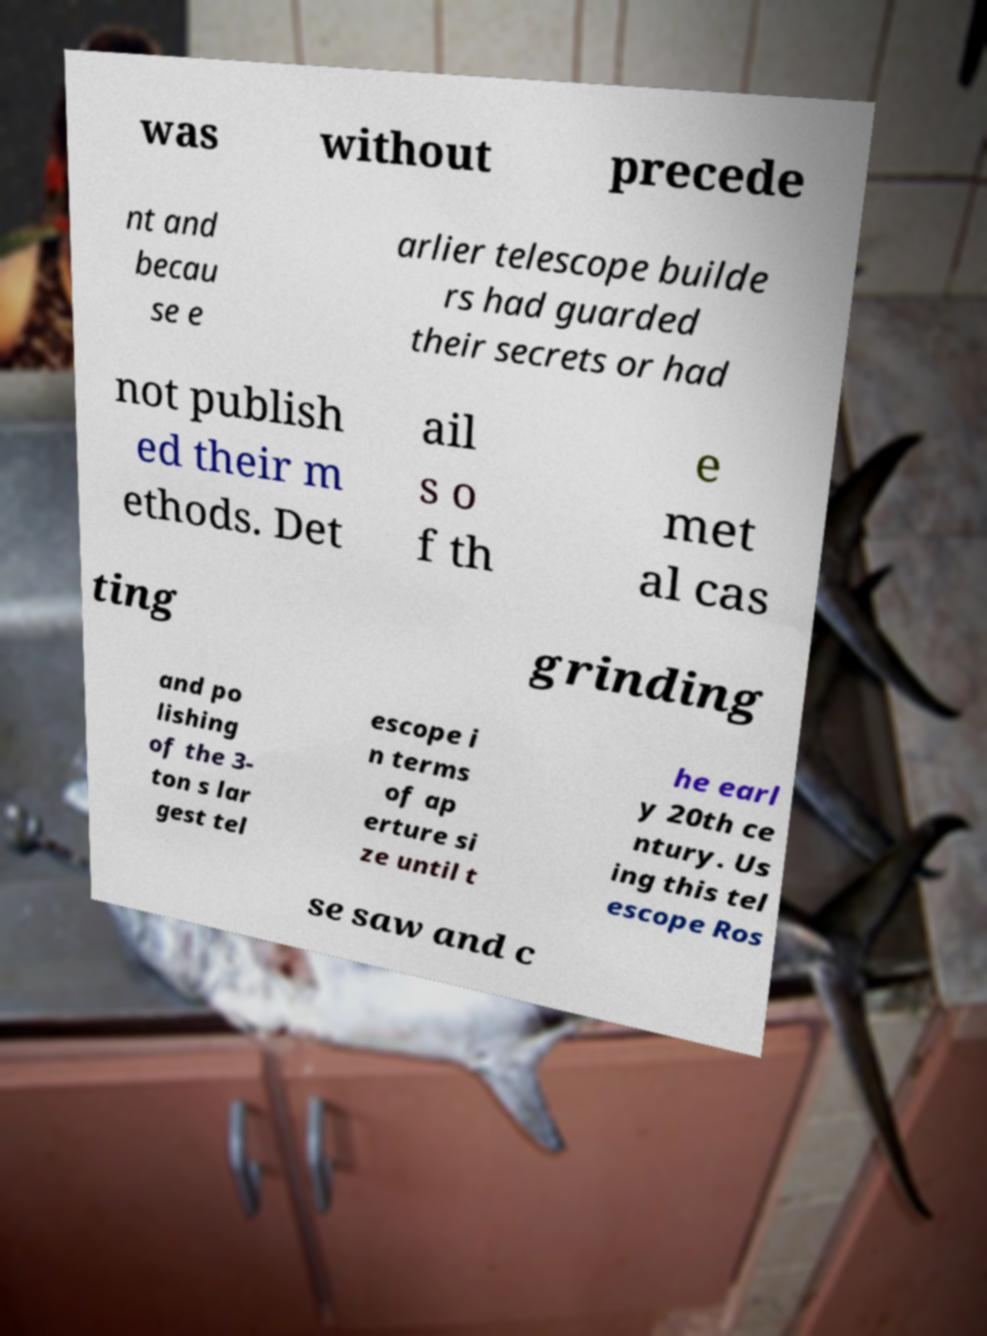Can you accurately transcribe the text from the provided image for me? was without precede nt and becau se e arlier telescope builde rs had guarded their secrets or had not publish ed their m ethods. Det ail s o f th e met al cas ting grinding and po lishing of the 3- ton s lar gest tel escope i n terms of ap erture si ze until t he earl y 20th ce ntury. Us ing this tel escope Ros se saw and c 